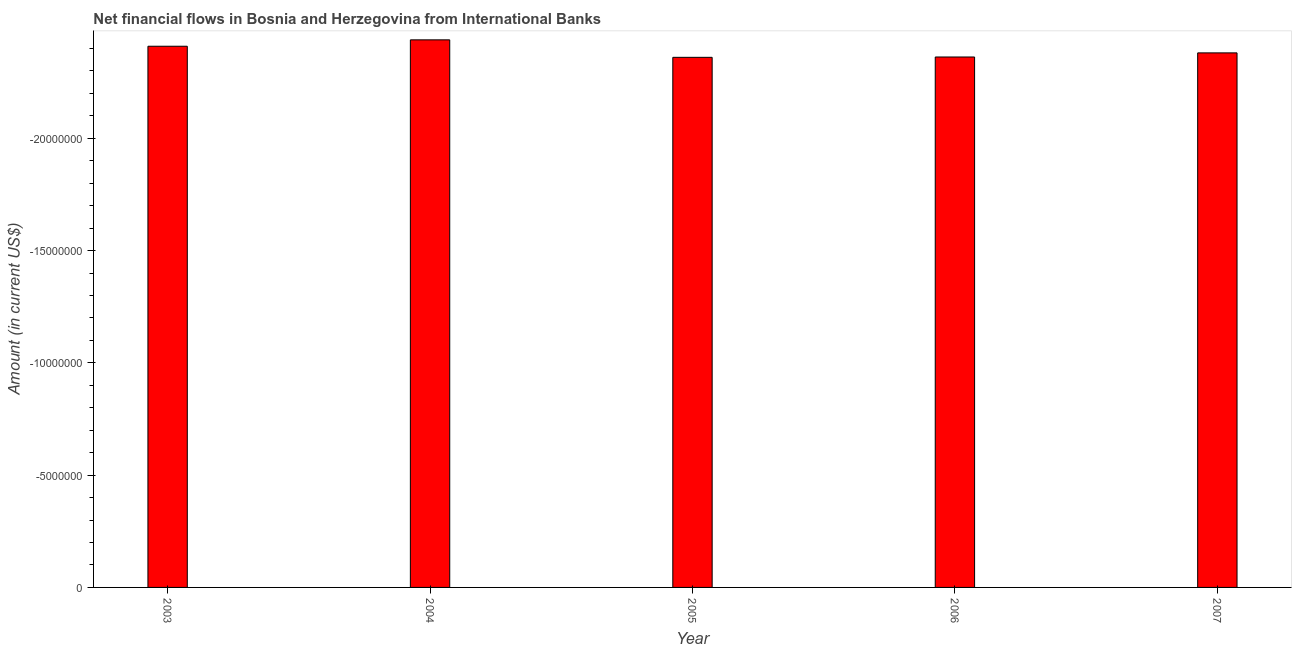Does the graph contain grids?
Offer a very short reply. No. What is the title of the graph?
Offer a very short reply. Net financial flows in Bosnia and Herzegovina from International Banks. What is the median net financial flows from ibrd?
Provide a short and direct response. 0. In how many years, is the net financial flows from ibrd greater than the average net financial flows from ibrd taken over all years?
Give a very brief answer. 0. How many bars are there?
Your answer should be compact. 0. What is the difference between two consecutive major ticks on the Y-axis?
Your answer should be compact. 5.00e+06. What is the Amount (in current US$) in 2004?
Keep it short and to the point. 0. What is the Amount (in current US$) of 2005?
Your response must be concise. 0. What is the Amount (in current US$) in 2006?
Provide a succinct answer. 0. 